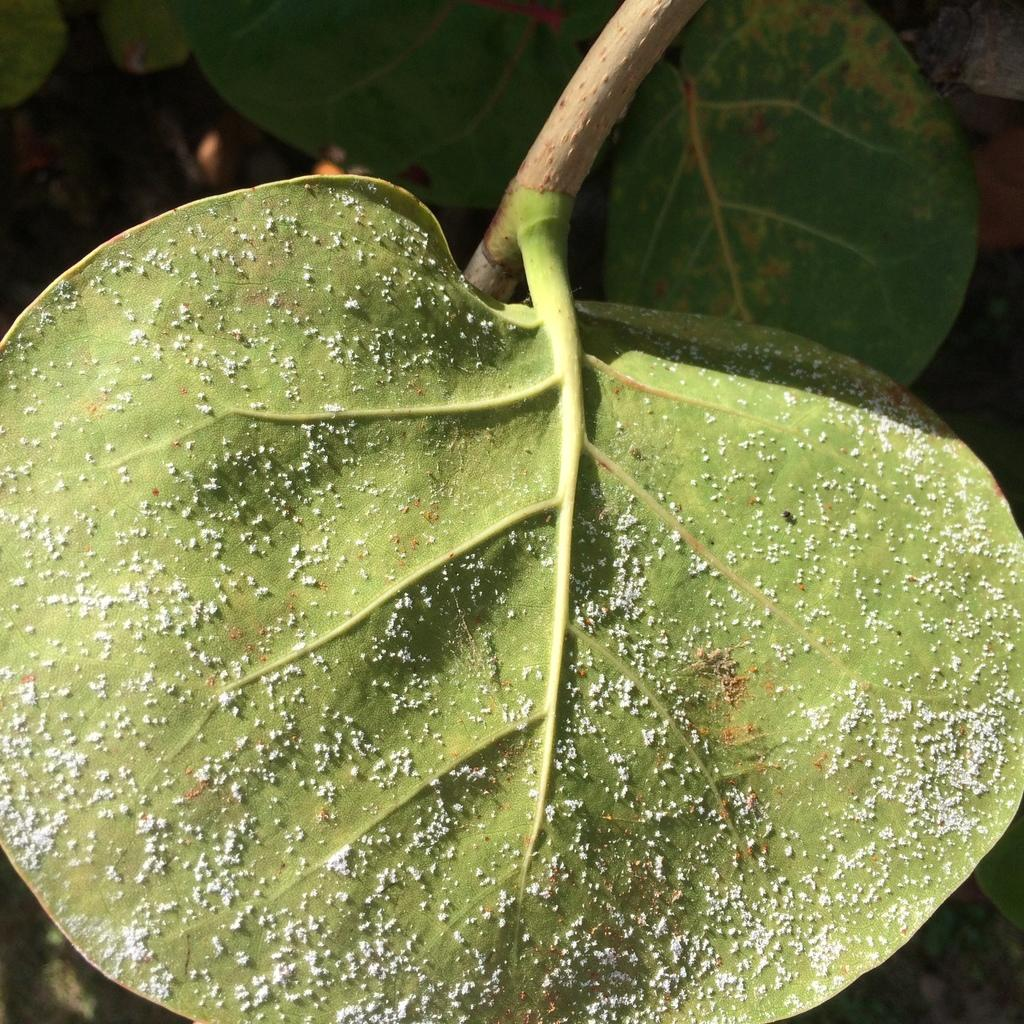What type of vegetation is present in the image? There are green leaves in the image. What type of gate is visible in the image? There is no gate present in the image; it only features green leaves. What shape does the heart have in the image? There is no heart present in the image; it only features green leaves. 